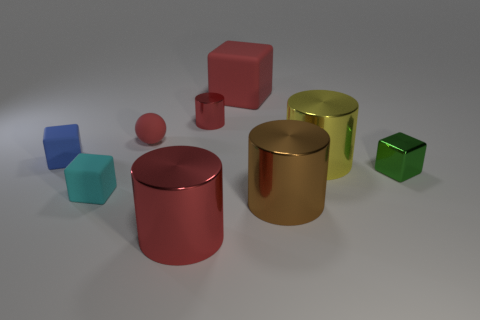Subtract all small blocks. How many blocks are left? 1 Subtract 3 cubes. How many cubes are left? 1 Subtract all yellow cylinders. How many cylinders are left? 3 Subtract all brown cylinders. How many green blocks are left? 1 Subtract all balls. How many objects are left? 8 Subtract all brown balls. Subtract all purple cylinders. How many balls are left? 1 Subtract 1 green cubes. How many objects are left? 8 Subtract all large cyan metal balls. Subtract all matte blocks. How many objects are left? 6 Add 5 blue cubes. How many blue cubes are left? 6 Add 9 green things. How many green things exist? 10 